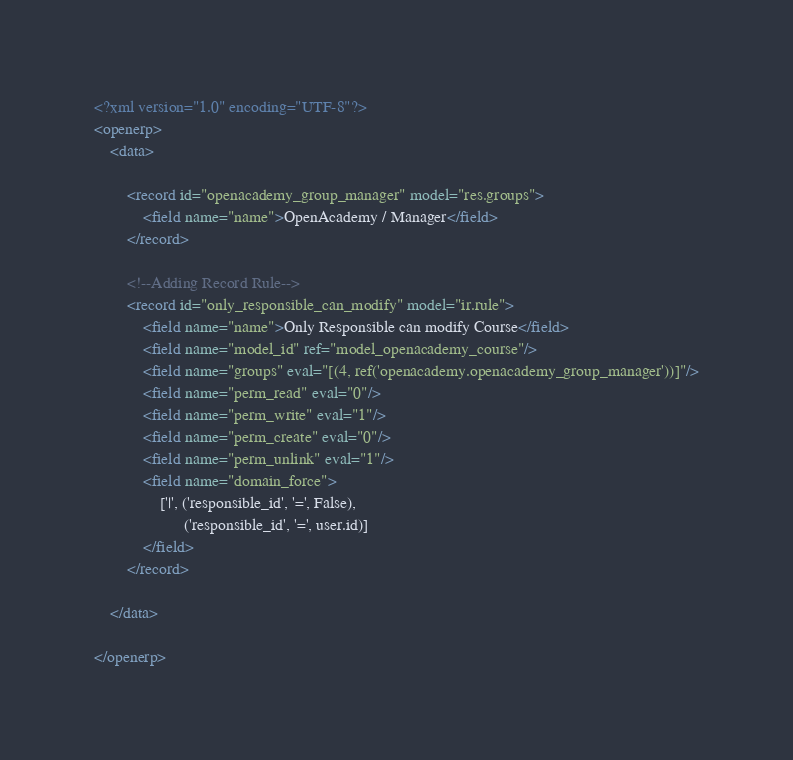Convert code to text. <code><loc_0><loc_0><loc_500><loc_500><_XML_><?xml version="1.0" encoding="UTF-8"?>
<openerp>
    <data>

        <record id="openacademy_group_manager" model="res.groups">
            <field name="name">OpenAcademy / Manager</field>
        </record>

        <!--Adding Record Rule-->
        <record id="only_responsible_can_modify" model="ir.rule">
            <field name="name">Only Responsible can modify Course</field>
            <field name="model_id" ref="model_openacademy_course"/>
            <field name="groups" eval="[(4, ref('openacademy.openacademy_group_manager'))]"/>
            <field name="perm_read" eval="0"/>
            <field name="perm_write" eval="1"/>
            <field name="perm_create" eval="0"/>
            <field name="perm_unlink" eval="1"/>
            <field name="domain_force">
                ['|', ('responsible_id', '=', False),
                      ('responsible_id', '=', user.id)]
            </field>
        </record>

    </data>

</openerp>

</code> 